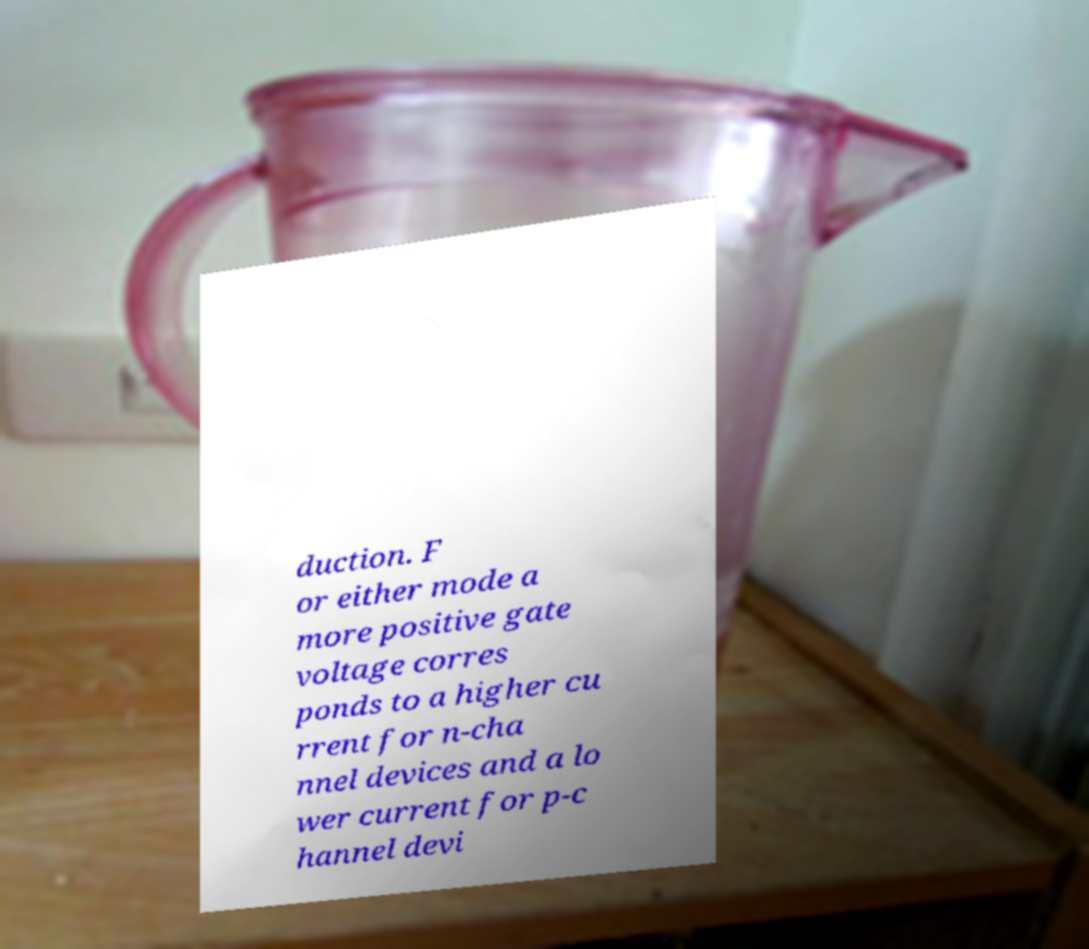For documentation purposes, I need the text within this image transcribed. Could you provide that? duction. F or either mode a more positive gate voltage corres ponds to a higher cu rrent for n-cha nnel devices and a lo wer current for p-c hannel devi 